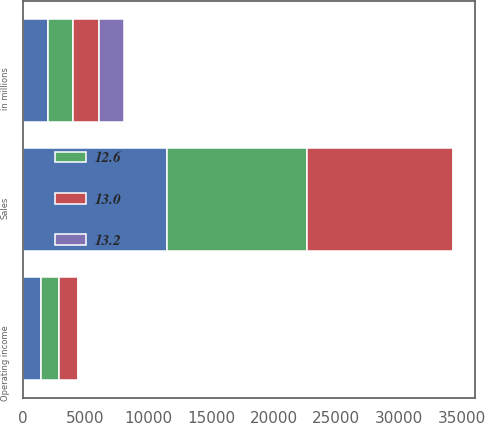<chart> <loc_0><loc_0><loc_500><loc_500><stacked_bar_chart><ecel><fcel>in millions<fcel>Sales<fcel>Operating income<nl><fcel>13<fcel>2018<fcel>11709<fcel>1520<nl><fcel>nan<fcel>2017<fcel>11470<fcel>1442<nl><fcel>12.6<fcel>2016<fcel>11161<fcel>1468<nl><fcel>13.2<fcel>2018<fcel>2<fcel>5<nl></chart> 